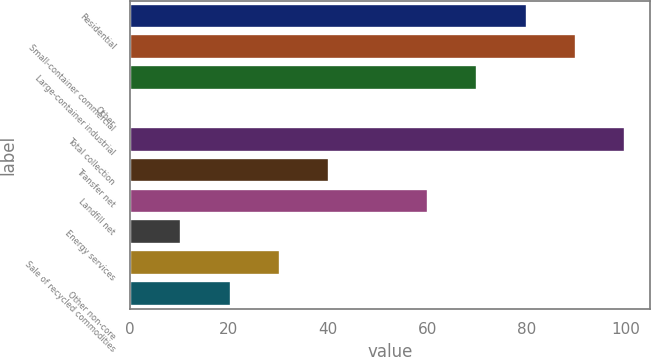Convert chart to OTSL. <chart><loc_0><loc_0><loc_500><loc_500><bar_chart><fcel>Residential<fcel>Small-container commercial<fcel>Large-container industrial<fcel>Other<fcel>Total collection<fcel>Transfer net<fcel>Landfill net<fcel>Energy services<fcel>Sale of recycled commodities<fcel>Other non-core<nl><fcel>80.08<fcel>90.04<fcel>70.12<fcel>0.4<fcel>100<fcel>40.24<fcel>60.16<fcel>10.36<fcel>30.28<fcel>20.32<nl></chart> 